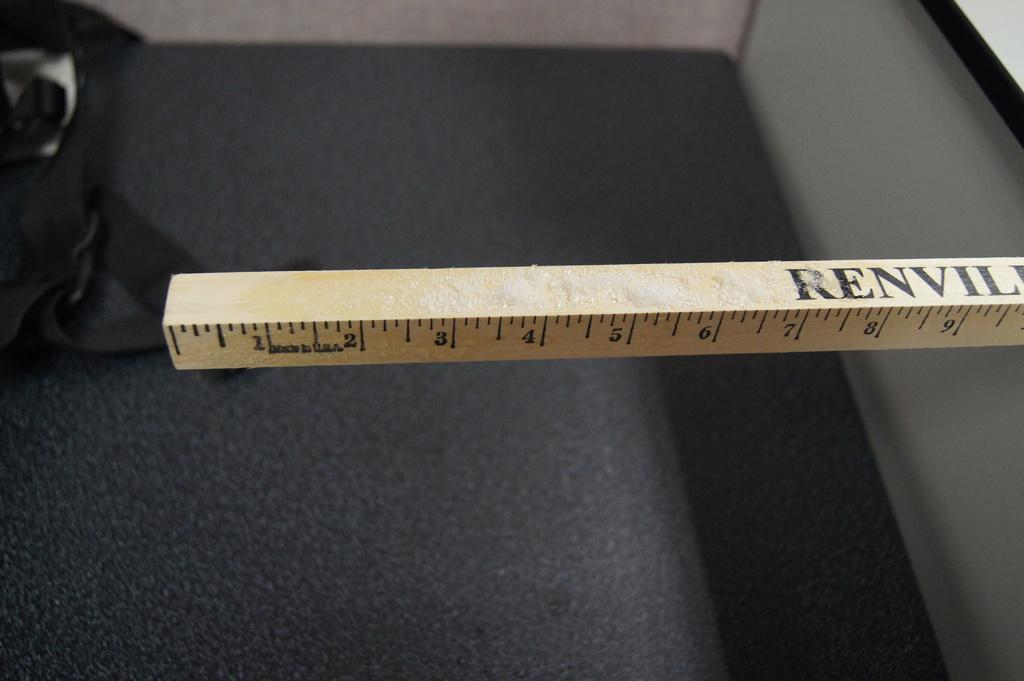<image>
Present a compact description of the photo's key features. A yardstick is marked with the phrase Made in USA between the 1 and 2.. 